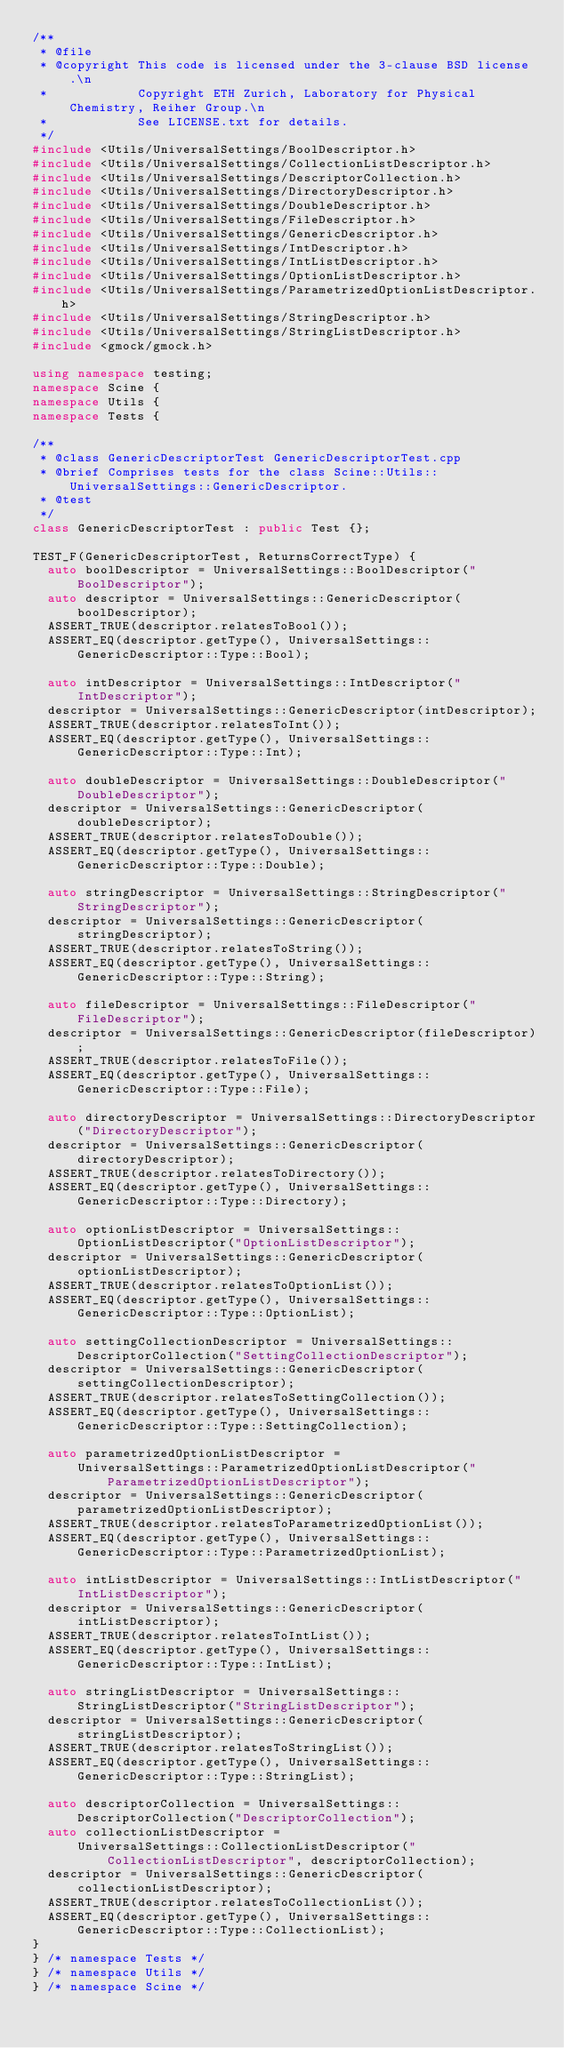Convert code to text. <code><loc_0><loc_0><loc_500><loc_500><_C++_>/**
 * @file
 * @copyright This code is licensed under the 3-clause BSD license.\n
 *            Copyright ETH Zurich, Laboratory for Physical Chemistry, Reiher Group.\n
 *            See LICENSE.txt for details.
 */
#include <Utils/UniversalSettings/BoolDescriptor.h>
#include <Utils/UniversalSettings/CollectionListDescriptor.h>
#include <Utils/UniversalSettings/DescriptorCollection.h>
#include <Utils/UniversalSettings/DirectoryDescriptor.h>
#include <Utils/UniversalSettings/DoubleDescriptor.h>
#include <Utils/UniversalSettings/FileDescriptor.h>
#include <Utils/UniversalSettings/GenericDescriptor.h>
#include <Utils/UniversalSettings/IntDescriptor.h>
#include <Utils/UniversalSettings/IntListDescriptor.h>
#include <Utils/UniversalSettings/OptionListDescriptor.h>
#include <Utils/UniversalSettings/ParametrizedOptionListDescriptor.h>
#include <Utils/UniversalSettings/StringDescriptor.h>
#include <Utils/UniversalSettings/StringListDescriptor.h>
#include <gmock/gmock.h>

using namespace testing;
namespace Scine {
namespace Utils {
namespace Tests {

/**
 * @class GenericDescriptorTest GenericDescriptorTest.cpp
 * @brief Comprises tests for the class Scine::Utils::UniversalSettings::GenericDescriptor.
 * @test
 */
class GenericDescriptorTest : public Test {};

TEST_F(GenericDescriptorTest, ReturnsCorrectType) {
  auto boolDescriptor = UniversalSettings::BoolDescriptor("BoolDescriptor");
  auto descriptor = UniversalSettings::GenericDescriptor(boolDescriptor);
  ASSERT_TRUE(descriptor.relatesToBool());
  ASSERT_EQ(descriptor.getType(), UniversalSettings::GenericDescriptor::Type::Bool);

  auto intDescriptor = UniversalSettings::IntDescriptor("IntDescriptor");
  descriptor = UniversalSettings::GenericDescriptor(intDescriptor);
  ASSERT_TRUE(descriptor.relatesToInt());
  ASSERT_EQ(descriptor.getType(), UniversalSettings::GenericDescriptor::Type::Int);

  auto doubleDescriptor = UniversalSettings::DoubleDescriptor("DoubleDescriptor");
  descriptor = UniversalSettings::GenericDescriptor(doubleDescriptor);
  ASSERT_TRUE(descriptor.relatesToDouble());
  ASSERT_EQ(descriptor.getType(), UniversalSettings::GenericDescriptor::Type::Double);

  auto stringDescriptor = UniversalSettings::StringDescriptor("StringDescriptor");
  descriptor = UniversalSettings::GenericDescriptor(stringDescriptor);
  ASSERT_TRUE(descriptor.relatesToString());
  ASSERT_EQ(descriptor.getType(), UniversalSettings::GenericDescriptor::Type::String);

  auto fileDescriptor = UniversalSettings::FileDescriptor("FileDescriptor");
  descriptor = UniversalSettings::GenericDescriptor(fileDescriptor);
  ASSERT_TRUE(descriptor.relatesToFile());
  ASSERT_EQ(descriptor.getType(), UniversalSettings::GenericDescriptor::Type::File);

  auto directoryDescriptor = UniversalSettings::DirectoryDescriptor("DirectoryDescriptor");
  descriptor = UniversalSettings::GenericDescriptor(directoryDescriptor);
  ASSERT_TRUE(descriptor.relatesToDirectory());
  ASSERT_EQ(descriptor.getType(), UniversalSettings::GenericDescriptor::Type::Directory);

  auto optionListDescriptor = UniversalSettings::OptionListDescriptor("OptionListDescriptor");
  descriptor = UniversalSettings::GenericDescriptor(optionListDescriptor);
  ASSERT_TRUE(descriptor.relatesToOptionList());
  ASSERT_EQ(descriptor.getType(), UniversalSettings::GenericDescriptor::Type::OptionList);

  auto settingCollectionDescriptor = UniversalSettings::DescriptorCollection("SettingCollectionDescriptor");
  descriptor = UniversalSettings::GenericDescriptor(settingCollectionDescriptor);
  ASSERT_TRUE(descriptor.relatesToSettingCollection());
  ASSERT_EQ(descriptor.getType(), UniversalSettings::GenericDescriptor::Type::SettingCollection);

  auto parametrizedOptionListDescriptor =
      UniversalSettings::ParametrizedOptionListDescriptor("ParametrizedOptionListDescriptor");
  descriptor = UniversalSettings::GenericDescriptor(parametrizedOptionListDescriptor);
  ASSERT_TRUE(descriptor.relatesToParametrizedOptionList());
  ASSERT_EQ(descriptor.getType(), UniversalSettings::GenericDescriptor::Type::ParametrizedOptionList);

  auto intListDescriptor = UniversalSettings::IntListDescriptor("IntListDescriptor");
  descriptor = UniversalSettings::GenericDescriptor(intListDescriptor);
  ASSERT_TRUE(descriptor.relatesToIntList());
  ASSERT_EQ(descriptor.getType(), UniversalSettings::GenericDescriptor::Type::IntList);

  auto stringListDescriptor = UniversalSettings::StringListDescriptor("StringListDescriptor");
  descriptor = UniversalSettings::GenericDescriptor(stringListDescriptor);
  ASSERT_TRUE(descriptor.relatesToStringList());
  ASSERT_EQ(descriptor.getType(), UniversalSettings::GenericDescriptor::Type::StringList);

  auto descriptorCollection = UniversalSettings::DescriptorCollection("DescriptorCollection");
  auto collectionListDescriptor =
      UniversalSettings::CollectionListDescriptor("CollectionListDescriptor", descriptorCollection);
  descriptor = UniversalSettings::GenericDescriptor(collectionListDescriptor);
  ASSERT_TRUE(descriptor.relatesToCollectionList());
  ASSERT_EQ(descriptor.getType(), UniversalSettings::GenericDescriptor::Type::CollectionList);
}
} /* namespace Tests */
} /* namespace Utils */
} /* namespace Scine */
</code> 